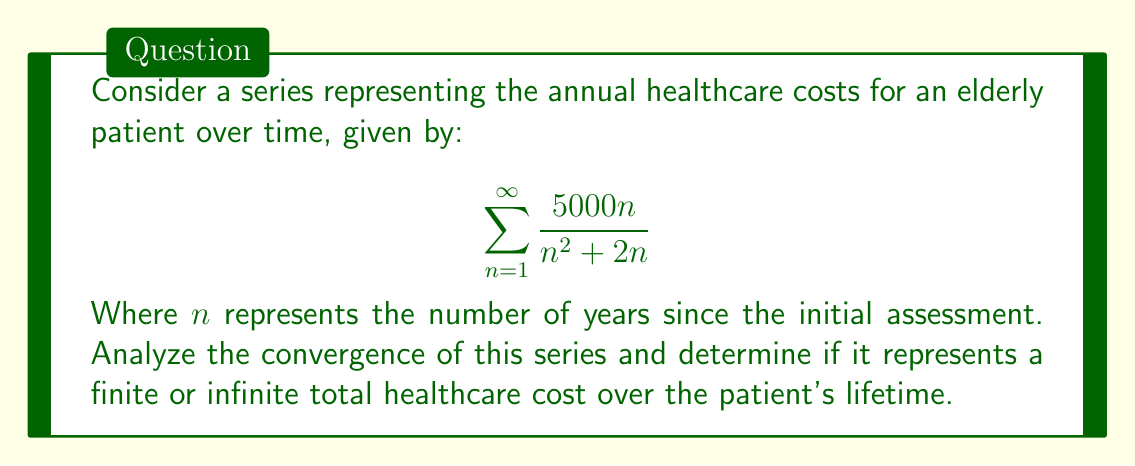Teach me how to tackle this problem. To analyze the convergence of this series, we'll use the limit comparison test with a known series.

1) First, let's simplify the general term of our series:

   $$a_n = \frac{5000n}{n^2 + 2n} = \frac{5000}{n + 2}$$

2) Now, let's compare this with the series $\sum \frac{1}{n}$, which is a known divergent series (the harmonic series).

3) We'll calculate the limit of the ratio of these terms:

   $$\lim_{n \to \infty} \frac{a_n}{\frac{1}{n}} = \lim_{n \to \infty} \frac{\frac{5000}{n + 2}}{\frac{1}{n}} = \lim_{n \to \infty} \frac{5000n}{n + 2}$$

4) As $n$ approaches infinity, this limit approaches 5000:

   $$\lim_{n \to \infty} \frac{5000n}{n + 2} = 5000$$

5) Since this limit is a non-zero finite value (5000), by the limit comparison test, our series converges if and only if $\sum \frac{1}{n}$ converges.

6) However, we know that $\sum \frac{1}{n}$ (the harmonic series) diverges.

Therefore, our original series also diverges.
Answer: The series $\sum_{n=1}^{\infty} \frac{5000n}{n^2 + 2n}$ diverges, representing an infinite total healthcare cost over the patient's lifetime. 